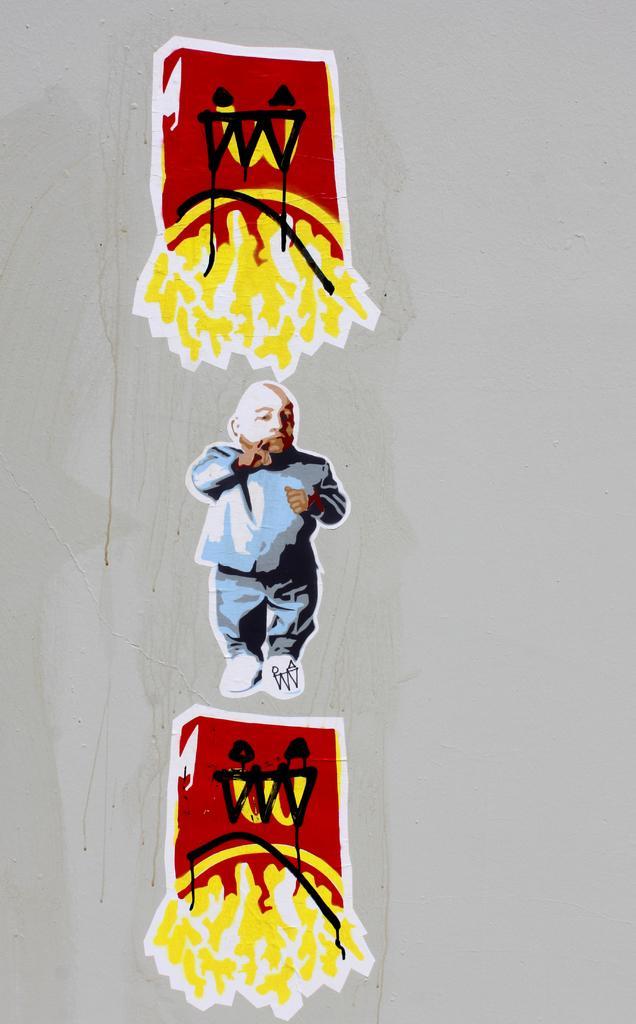Can you describe this image briefly? In this image we can see a painting of a person and other objects on the wall. 